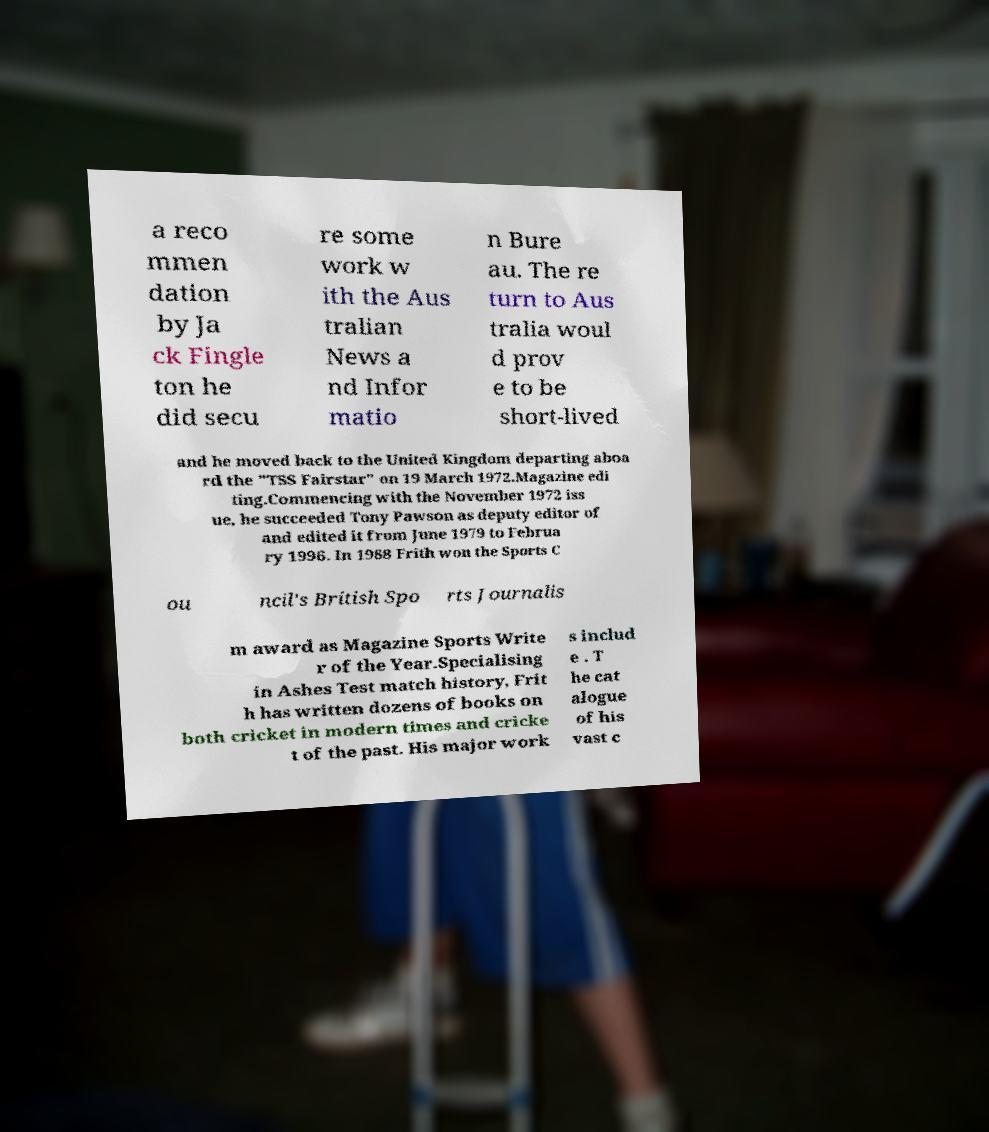Can you read and provide the text displayed in the image?This photo seems to have some interesting text. Can you extract and type it out for me? a reco mmen dation by Ja ck Fingle ton he did secu re some work w ith the Aus tralian News a nd Infor matio n Bure au. The re turn to Aus tralia woul d prov e to be short-lived and he moved back to the United Kingdom departing aboa rd the "TSS Fairstar" on 19 March 1972.Magazine edi ting.Commencing with the November 1972 iss ue, he succeeded Tony Pawson as deputy editor of and edited it from June 1979 to Februa ry 1996. In 1988 Frith won the Sports C ou ncil's British Spo rts Journalis m award as Magazine Sports Write r of the Year.Specialising in Ashes Test match history, Frit h has written dozens of books on both cricket in modern times and cricke t of the past. His major work s includ e . T he cat alogue of his vast c 